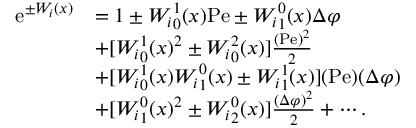<formula> <loc_0><loc_0><loc_500><loc_500>\begin{array} { r l } { e ^ { \pm W _ { i } ( x ) } } & { = 1 \pm { W _ { i } } _ { 0 } ^ { 1 } ( x ) P e \pm { W _ { i } } _ { 1 } ^ { 0 } ( x ) \Delta \varphi } \\ & { + [ { W _ { i } } _ { 0 } ^ { 1 } ( x ) ^ { 2 } \pm { W _ { i } } _ { 0 } ^ { 2 } ( x ) ] \frac { ( P e ) ^ { 2 } } { 2 } } \\ & { + [ { W _ { i } } _ { 0 } ^ { 1 } ( x ) { W _ { i } } _ { 1 } ^ { 0 } ( x ) \pm { W _ { i } } _ { 1 } ^ { 1 } ( x ) ] ( P e ) ( \Delta \varphi ) } \\ & { + [ { W _ { i } } _ { 1 } ^ { 0 } ( x ) ^ { 2 } \pm { W _ { i } } _ { 2 } ^ { 0 } ( x ) ] \frac { ( \Delta \varphi ) ^ { 2 } } { 2 } + \cdots . } \end{array}</formula> 